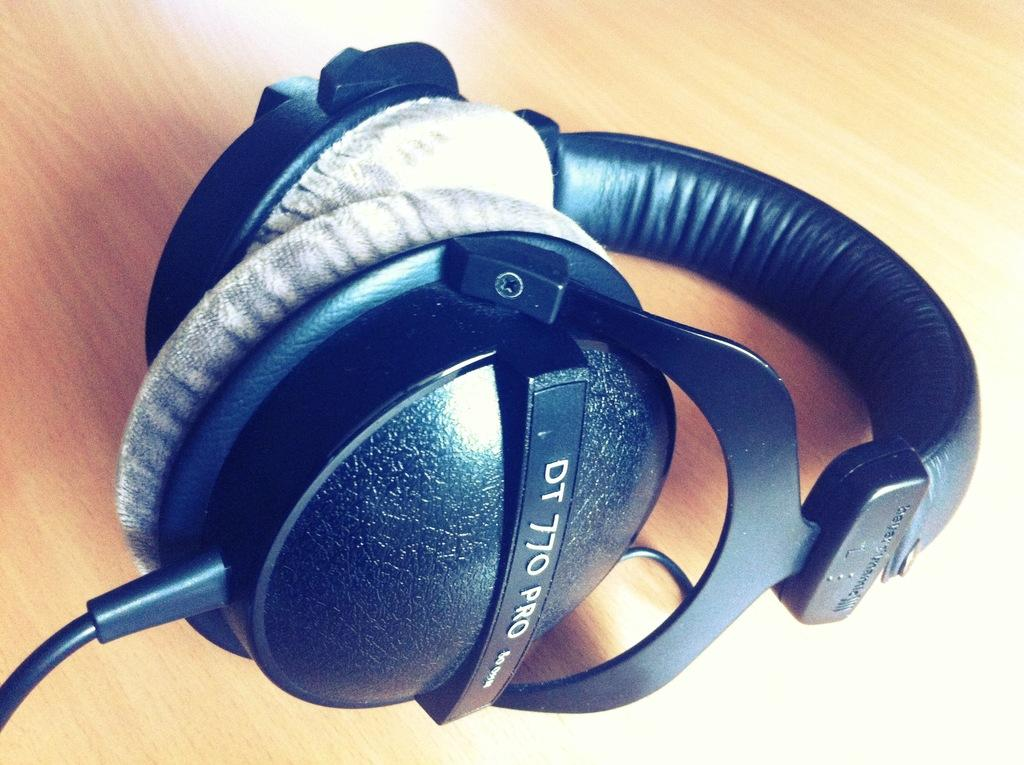What type of audio equipment is present in the image? There are headphones in the image. Where are the headphones located? The headphones are on a wooden table. What type of fang can be seen in the image? There is no fang present in the image; it features headphones on a wooden table. How do the acoustics of the room affect the sound quality of the headphones in the image? The provided facts do not mention any information about the room's acoustics, so it cannot be determined how they affect the sound quality of the headphones. 